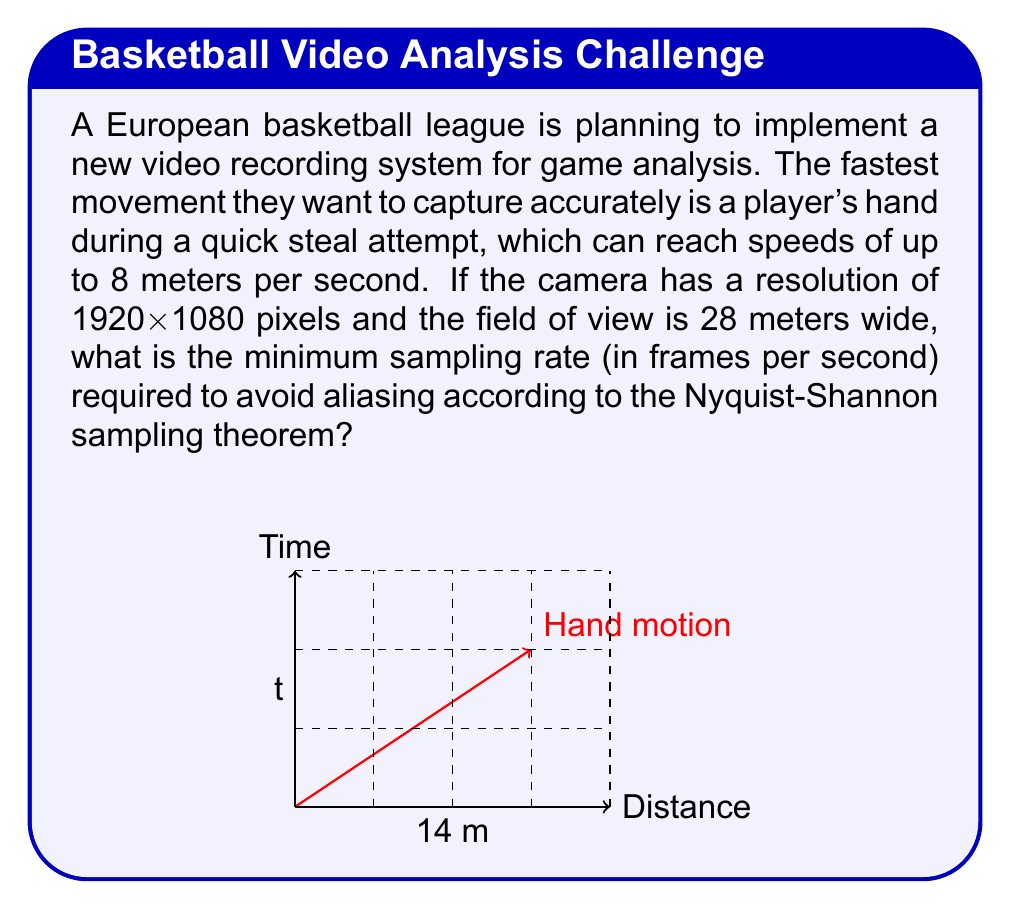Can you answer this question? To solve this problem, we'll use the Nyquist-Shannon sampling theorem and follow these steps:

1) First, we need to determine the highest frequency component in the signal. In this case, it's the fastest movement we want to capture.

2) Calculate the spatial frequency:
   - Field of view width = 28 meters
   - Image width = 1920 pixels
   - Pixels per meter = 1920 / 28 ≈ 68.57 pixels/meter

3) Calculate the time it takes for the hand to move one pixel:
   - Hand speed = 8 meters/second
   - Time to move 1 meter = 1 / 8 = 0.125 seconds
   - Time to move 1 pixel = 0.125 / 68.57 ≈ 0.00182 seconds

4) The frequency of this movement is:
   $f = \frac{1}{0.00182} \approx 549.45$ Hz

5) According to the Nyquist-Shannon theorem, the sampling frequency must be at least twice the highest frequency component:

   $f_s \geq 2f$

   $f_s \geq 2 * 549.45 = 1098.9$ Hz

6) Therefore, the minimum sampling rate should be at least 1099 frames per second (rounding up to the nearest whole number).
Answer: 1099 fps 